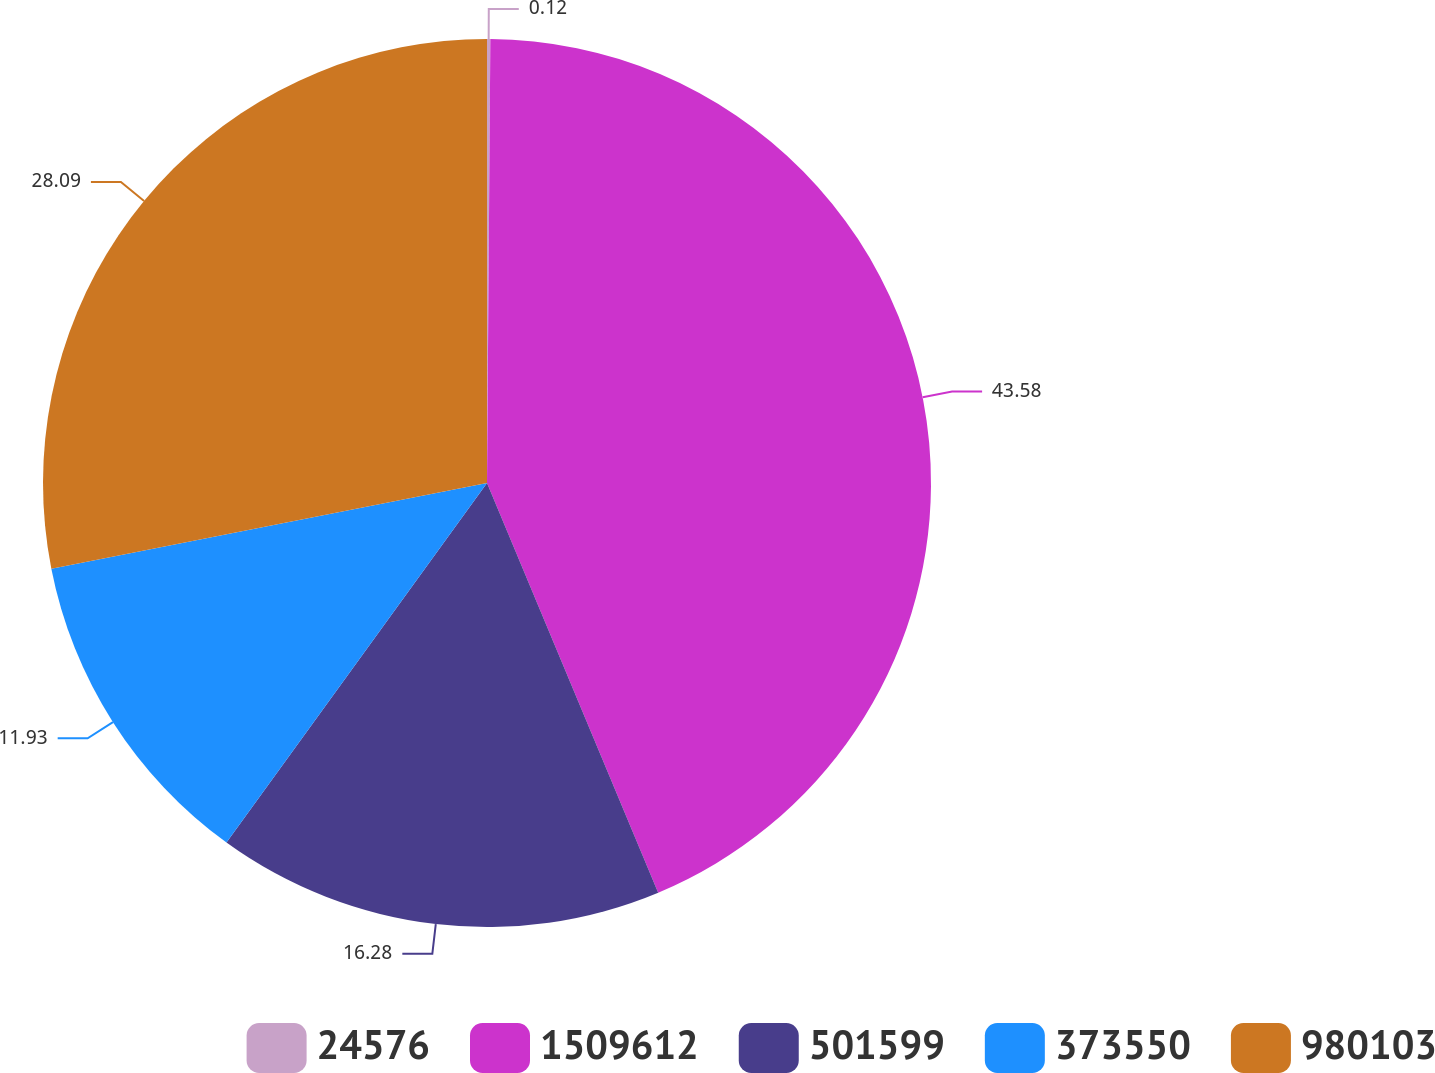Convert chart. <chart><loc_0><loc_0><loc_500><loc_500><pie_chart><fcel>24576<fcel>1509612<fcel>501599<fcel>373550<fcel>980103<nl><fcel>0.12%<fcel>43.58%<fcel>16.28%<fcel>11.93%<fcel>28.09%<nl></chart> 